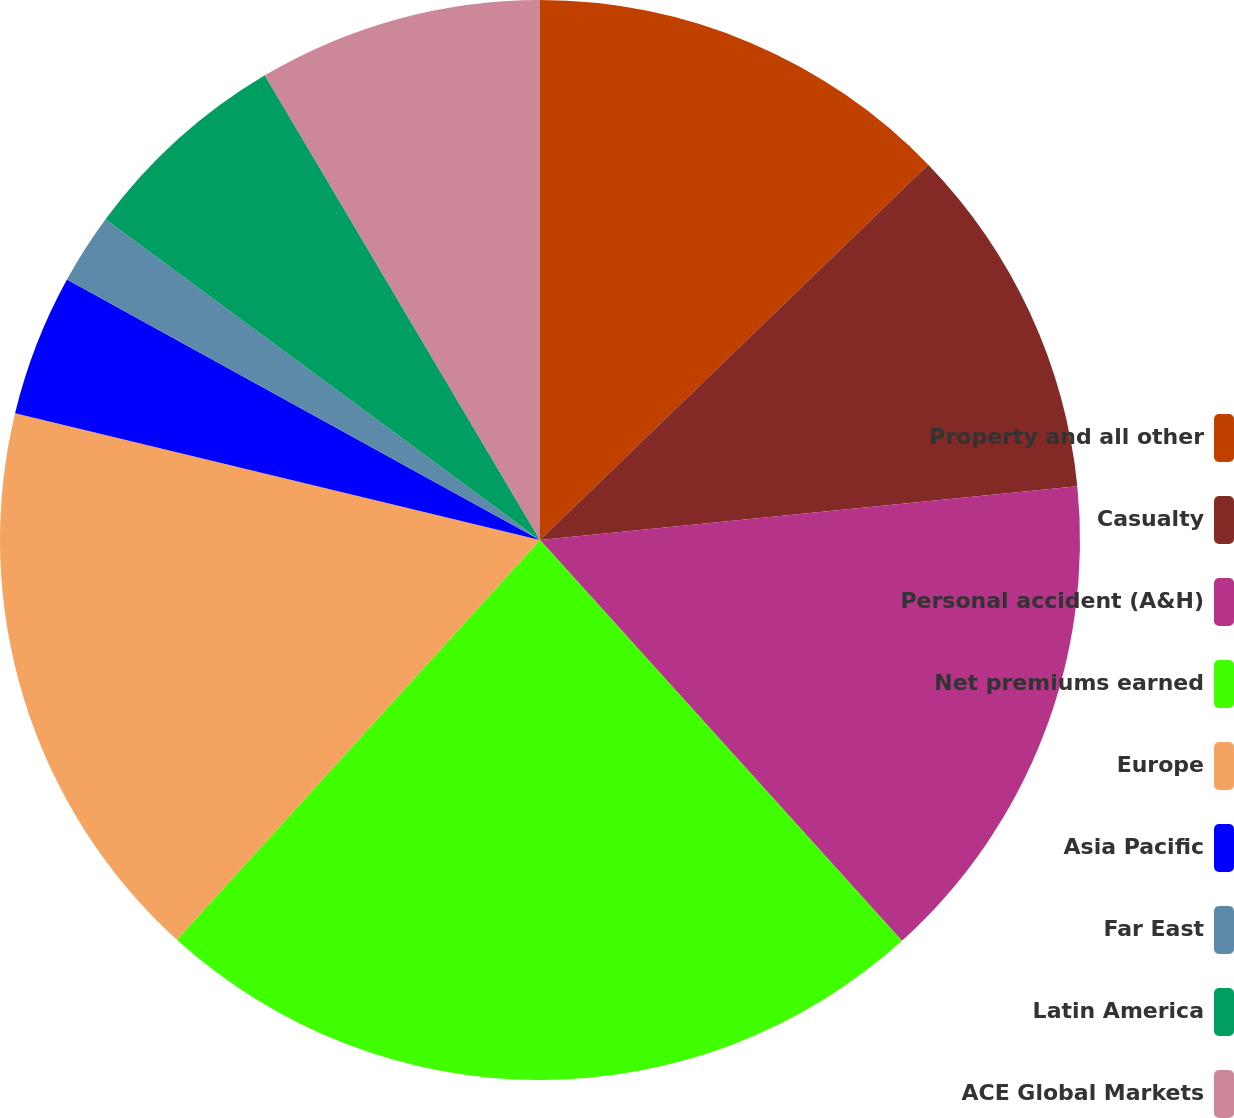Convert chart to OTSL. <chart><loc_0><loc_0><loc_500><loc_500><pie_chart><fcel>Property and all other<fcel>Casualty<fcel>Personal accident (A&H)<fcel>Net premiums earned<fcel>Europe<fcel>Asia Pacific<fcel>Far East<fcel>Latin America<fcel>ACE Global Markets<nl><fcel>12.77%<fcel>10.64%<fcel>14.9%<fcel>23.43%<fcel>17.03%<fcel>4.24%<fcel>2.11%<fcel>6.37%<fcel>8.51%<nl></chart> 